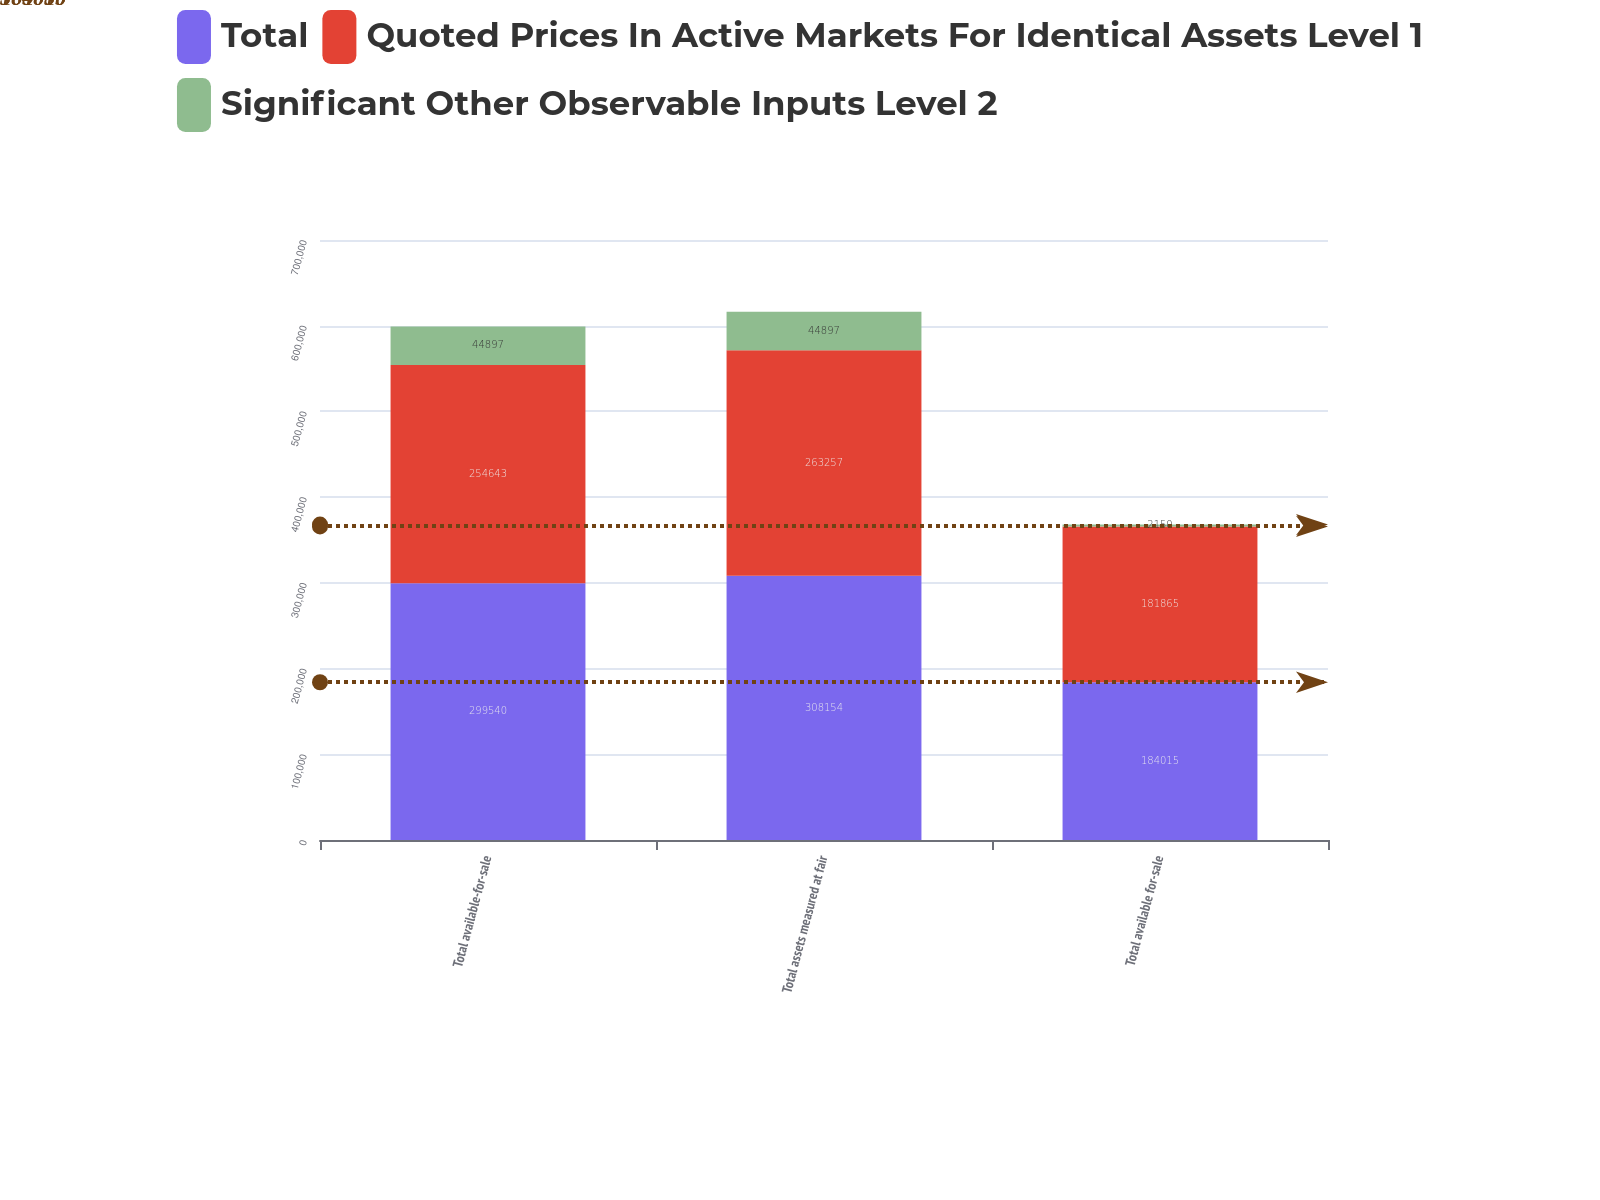Convert chart. <chart><loc_0><loc_0><loc_500><loc_500><stacked_bar_chart><ecel><fcel>Total available-for-sale<fcel>Total assets measured at fair<fcel>Total available for-sale<nl><fcel>Total<fcel>299540<fcel>308154<fcel>184015<nl><fcel>Quoted Prices In Active Markets For Identical Assets Level 1<fcel>254643<fcel>263257<fcel>181865<nl><fcel>Significant Other Observable Inputs Level 2<fcel>44897<fcel>44897<fcel>2150<nl></chart> 